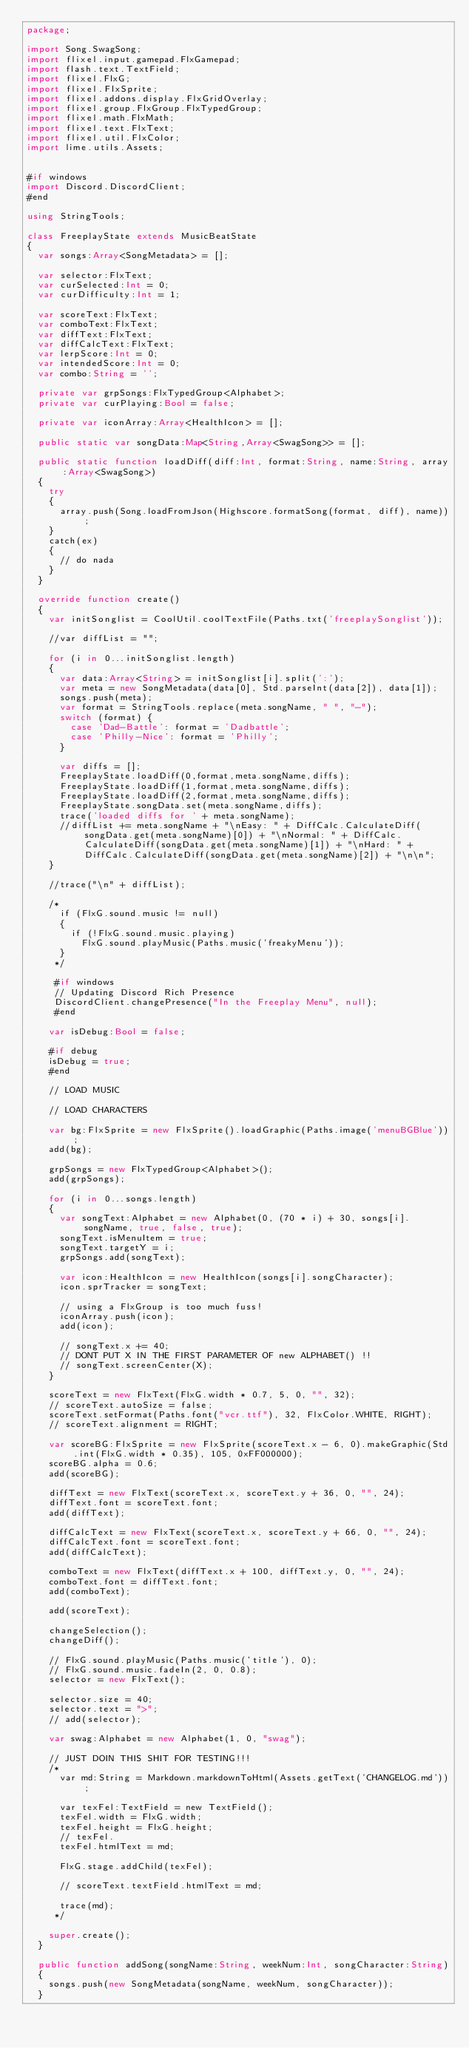<code> <loc_0><loc_0><loc_500><loc_500><_Haxe_>package;

import Song.SwagSong;
import flixel.input.gamepad.FlxGamepad;
import flash.text.TextField;
import flixel.FlxG;
import flixel.FlxSprite;
import flixel.addons.display.FlxGridOverlay;
import flixel.group.FlxGroup.FlxTypedGroup;
import flixel.math.FlxMath;
import flixel.text.FlxText;
import flixel.util.FlxColor;
import lime.utils.Assets;


#if windows
import Discord.DiscordClient;
#end

using StringTools;

class FreeplayState extends MusicBeatState
{
	var songs:Array<SongMetadata> = [];

	var selector:FlxText;
	var curSelected:Int = 0;
	var curDifficulty:Int = 1;

	var scoreText:FlxText;
	var comboText:FlxText;
	var diffText:FlxText;
	var diffCalcText:FlxText;
	var lerpScore:Int = 0;
	var intendedScore:Int = 0;
	var combo:String = '';

	private var grpSongs:FlxTypedGroup<Alphabet>;
	private var curPlaying:Bool = false;

	private var iconArray:Array<HealthIcon> = [];

	public static var songData:Map<String,Array<SwagSong>> = [];

	public static function loadDiff(diff:Int, format:String, name:String, array:Array<SwagSong>)
	{
		try 
		{
			array.push(Song.loadFromJson(Highscore.formatSong(format, diff), name));
		}
		catch(ex)
		{
			// do nada
		}
	}

	override function create()
	{
		var initSonglist = CoolUtil.coolTextFile(Paths.txt('freeplaySonglist'));

		//var diffList = "";

		for (i in 0...initSonglist.length)
		{
			var data:Array<String> = initSonglist[i].split(':');
			var meta = new SongMetadata(data[0], Std.parseInt(data[2]), data[1]);
			songs.push(meta);
			var format = StringTools.replace(meta.songName, " ", "-");
			switch (format) {
				case 'Dad-Battle': format = 'Dadbattle';
				case 'Philly-Nice': format = 'Philly';
			}

			var diffs = [];
			FreeplayState.loadDiff(0,format,meta.songName,diffs);
			FreeplayState.loadDiff(1,format,meta.songName,diffs);
			FreeplayState.loadDiff(2,format,meta.songName,diffs);
			FreeplayState.songData.set(meta.songName,diffs);
			trace('loaded diffs for ' + meta.songName);
			//diffList += meta.songName + "\nEasy: " + DiffCalc.CalculateDiff(songData.get(meta.songName)[0]) + "\nNormal: " + DiffCalc.CalculateDiff(songData.get(meta.songName)[1]) + "\nHard: " + DiffCalc.CalculateDiff(songData.get(meta.songName)[2]) + "\n\n";
		}

		//trace("\n" + diffList);

		/* 
			if (FlxG.sound.music != null)
			{
				if (!FlxG.sound.music.playing)
					FlxG.sound.playMusic(Paths.music('freakyMenu'));
			}
		 */

		 #if windows
		 // Updating Discord Rich Presence
		 DiscordClient.changePresence("In the Freeplay Menu", null);
		 #end

		var isDebug:Bool = false;

		#if debug
		isDebug = true;
		#end

		// LOAD MUSIC

		// LOAD CHARACTERS

		var bg:FlxSprite = new FlxSprite().loadGraphic(Paths.image('menuBGBlue'));
		add(bg);

		grpSongs = new FlxTypedGroup<Alphabet>();
		add(grpSongs);

		for (i in 0...songs.length)
		{
			var songText:Alphabet = new Alphabet(0, (70 * i) + 30, songs[i].songName, true, false, true);
			songText.isMenuItem = true;
			songText.targetY = i;
			grpSongs.add(songText);

			var icon:HealthIcon = new HealthIcon(songs[i].songCharacter);
			icon.sprTracker = songText;

			// using a FlxGroup is too much fuss!
			iconArray.push(icon);
			add(icon);

			// songText.x += 40;
			// DONT PUT X IN THE FIRST PARAMETER OF new ALPHABET() !!
			// songText.screenCenter(X);
		}

		scoreText = new FlxText(FlxG.width * 0.7, 5, 0, "", 32);
		// scoreText.autoSize = false;
		scoreText.setFormat(Paths.font("vcr.ttf"), 32, FlxColor.WHITE, RIGHT);
		// scoreText.alignment = RIGHT;

		var scoreBG:FlxSprite = new FlxSprite(scoreText.x - 6, 0).makeGraphic(Std.int(FlxG.width * 0.35), 105, 0xFF000000);
		scoreBG.alpha = 0.6;
		add(scoreBG);

		diffText = new FlxText(scoreText.x, scoreText.y + 36, 0, "", 24);
		diffText.font = scoreText.font;
		add(diffText);

		diffCalcText = new FlxText(scoreText.x, scoreText.y + 66, 0, "", 24);
		diffCalcText.font = scoreText.font;
		add(diffCalcText);

		comboText = new FlxText(diffText.x + 100, diffText.y, 0, "", 24);
		comboText.font = diffText.font;
		add(comboText);

		add(scoreText);

		changeSelection();
		changeDiff();

		// FlxG.sound.playMusic(Paths.music('title'), 0);
		// FlxG.sound.music.fadeIn(2, 0, 0.8);
		selector = new FlxText();

		selector.size = 40;
		selector.text = ">";
		// add(selector);

		var swag:Alphabet = new Alphabet(1, 0, "swag");

		// JUST DOIN THIS SHIT FOR TESTING!!!
		/* 
			var md:String = Markdown.markdownToHtml(Assets.getText('CHANGELOG.md'));

			var texFel:TextField = new TextField();
			texFel.width = FlxG.width;
			texFel.height = FlxG.height;
			// texFel.
			texFel.htmlText = md;

			FlxG.stage.addChild(texFel);

			// scoreText.textField.htmlText = md;

			trace(md);
		 */

		super.create();
	}

	public function addSong(songName:String, weekNum:Int, songCharacter:String)
	{
		songs.push(new SongMetadata(songName, weekNum, songCharacter));
	}
</code> 